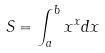<formula> <loc_0><loc_0><loc_500><loc_500>S = \int _ { a } ^ { b } x ^ { x } d x</formula> 